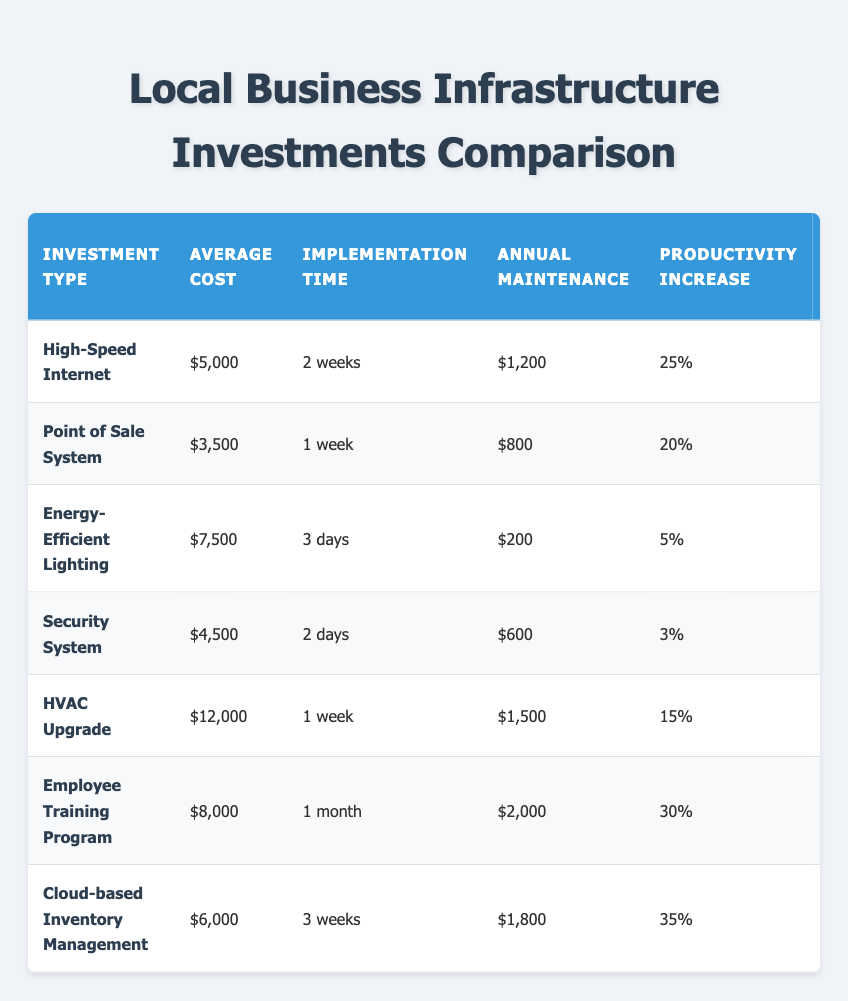What is the average cost of all the investments listed? To find the average cost, list the costs: 5000, 3500, 7500, 4500, 12000, 8000, and 6000. Add these values up: 5000 + 3500 + 7500 + 4500 + 12000 + 8000 + 6000 = 50000. There are 7 investments, so divide the total by 7. Therefore, the average cost is 50000 / 7 = approximately 7142.86.
Answer: 7142.86 Which investment has the highest productivity increase? The productivity increases are 25%, 20%, 5%, 3%, 15%, 30%, and 35%. The highest value among these is 35%, which corresponds to the Cloud-based Inventory Management.
Answer: Cloud-based Inventory Management Is the ROI for the Employee Training Program higher than that of the High-Speed Internet investment? The ROI for the Employee Training Program is 200% while the ROI for High-Speed Internet is 180%. Since 200% is greater than 180%, the statement is true.
Answer: Yes What is the total annual maintenance cost for the Point of Sale System and Security System combined? The annual maintenance costs for both systems are 800 for the Point of Sale System and 600 for the Security System. Adding these together gives 800 + 600 = 1400.
Answer: 1400 If you sum the customer satisfaction boosts of the Energy-Efficient Lighting and HVAC Upgrade, what is the total? The customer satisfaction boosts are 10% for Energy-Efficient Lighting and 25% for HVAC Upgrade. Adding these yields 10 + 25 = 35.
Answer: 35 True or False: The average implementation time for all investments exceeds 1 week. The implementation times are as follows: 2 weeks, 1 week, 3 days (0.43 weeks), 2 days (0.29 weeks), 1 week, 1 month (about 4.33 weeks), and 3 weeks. Convert all to weeks and find the average: 2 + 1 + 0.43 + 0.29 + 1 + 4.33 + 3 = 12.04 weeks for 7 investments, which gives an average of 12.04 / 7 = approximately 1.72 weeks. Since this is greater than 1 week, the statement is true.
Answer: True What is the ROI difference between the Cloud-based Inventory Management and Energy-Efficient Lighting? The ROI for Cloud-based Inventory Management is 170% and for Energy-Efficient Lighting it is 80%. To find the difference, subtract: 170 - 80 = 90.
Answer: 90 Name the investment type with the lowest ROI. The ROI values listed are 180%, 150%, 80%, 60%, 90%, 200%, and 170%. The lowest value is 60%, which corresponds to the Security System.
Answer: Security System 